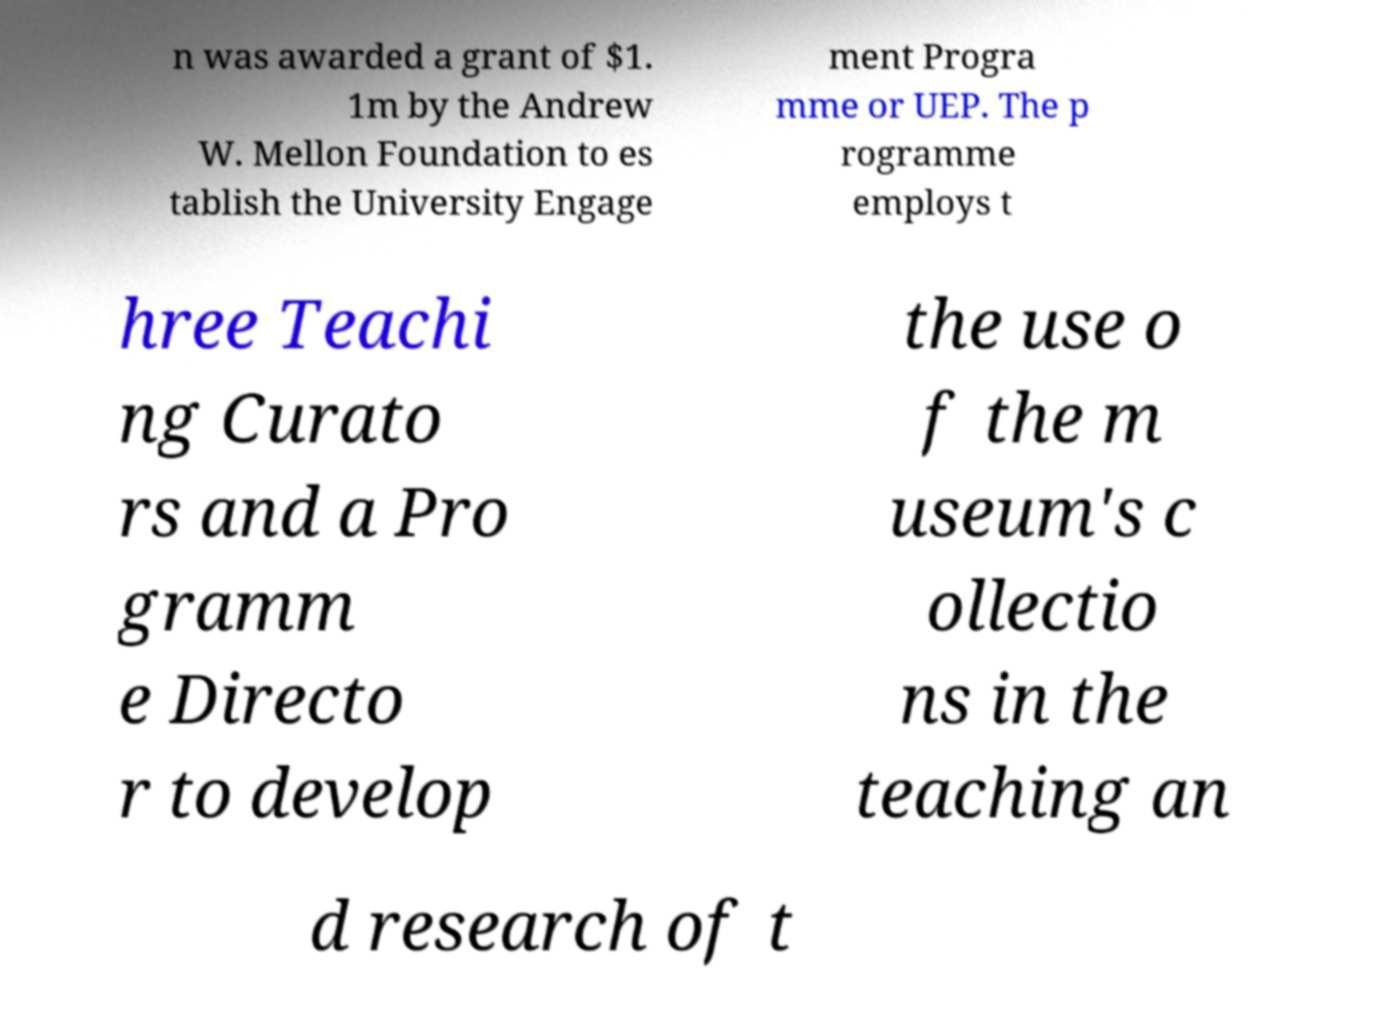What messages or text are displayed in this image? I need them in a readable, typed format. n was awarded a grant of $1. 1m by the Andrew W. Mellon Foundation to es tablish the University Engage ment Progra mme or UEP. The p rogramme employs t hree Teachi ng Curato rs and a Pro gramm e Directo r to develop the use o f the m useum's c ollectio ns in the teaching an d research of t 